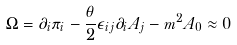Convert formula to latex. <formula><loc_0><loc_0><loc_500><loc_500>\Omega = \partial _ { i } \pi _ { i } - \frac { \theta } { 2 } \epsilon _ { i j } \partial _ { i } A _ { j } - m ^ { 2 } A _ { 0 } \approx 0</formula> 